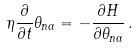<formula> <loc_0><loc_0><loc_500><loc_500>\eta \frac { \partial } { \partial t } \theta _ { { n } \alpha } = - \frac { \partial H } { \partial \theta _ { { n } \alpha } } \, .</formula> 